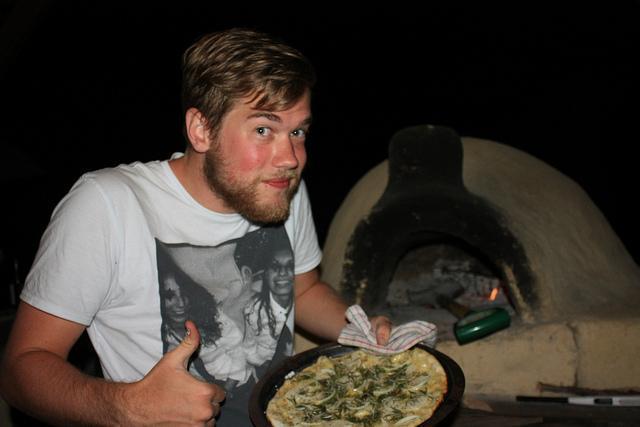How many pizzas are in the photo?
Give a very brief answer. 1. 